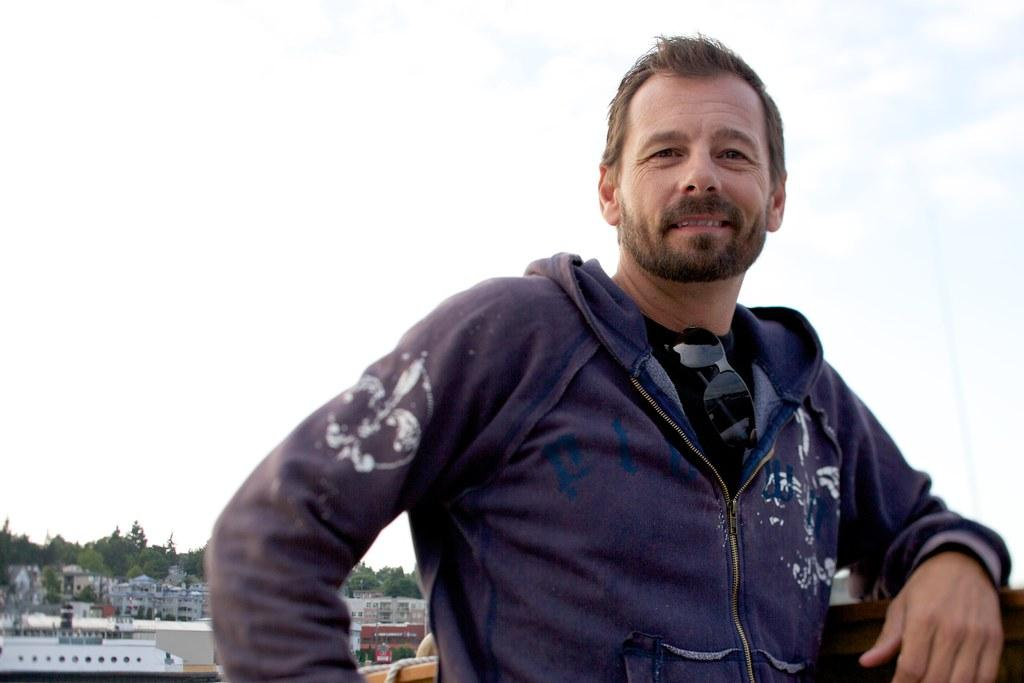What is the main subject of the image? There is a man standing in the middle of the image. What is the man's facial expression? The man is smiling. What can be seen in the background of the image? There are buildings and trees in the background of the image. What is visible at the top of the image? The sky is visible at the top of the image. What type of spoon is the man holding in the image? There is no spoon present in the image; the man is not holding anything. What color is the edge of the sky in the image? The sky does not have an edge in the image, and its color cannot be determined. 